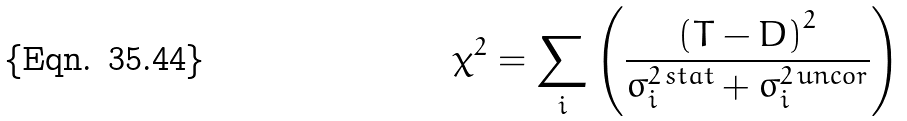<formula> <loc_0><loc_0><loc_500><loc_500>\chi ^ { 2 } = \sum _ { i } \left ( \frac { \left ( T - D \right ) ^ { 2 } } { \sigma _ { i } ^ { 2 \, s t a t } + \sigma _ { i } ^ { 2 \, u n c o r } } \right )</formula> 